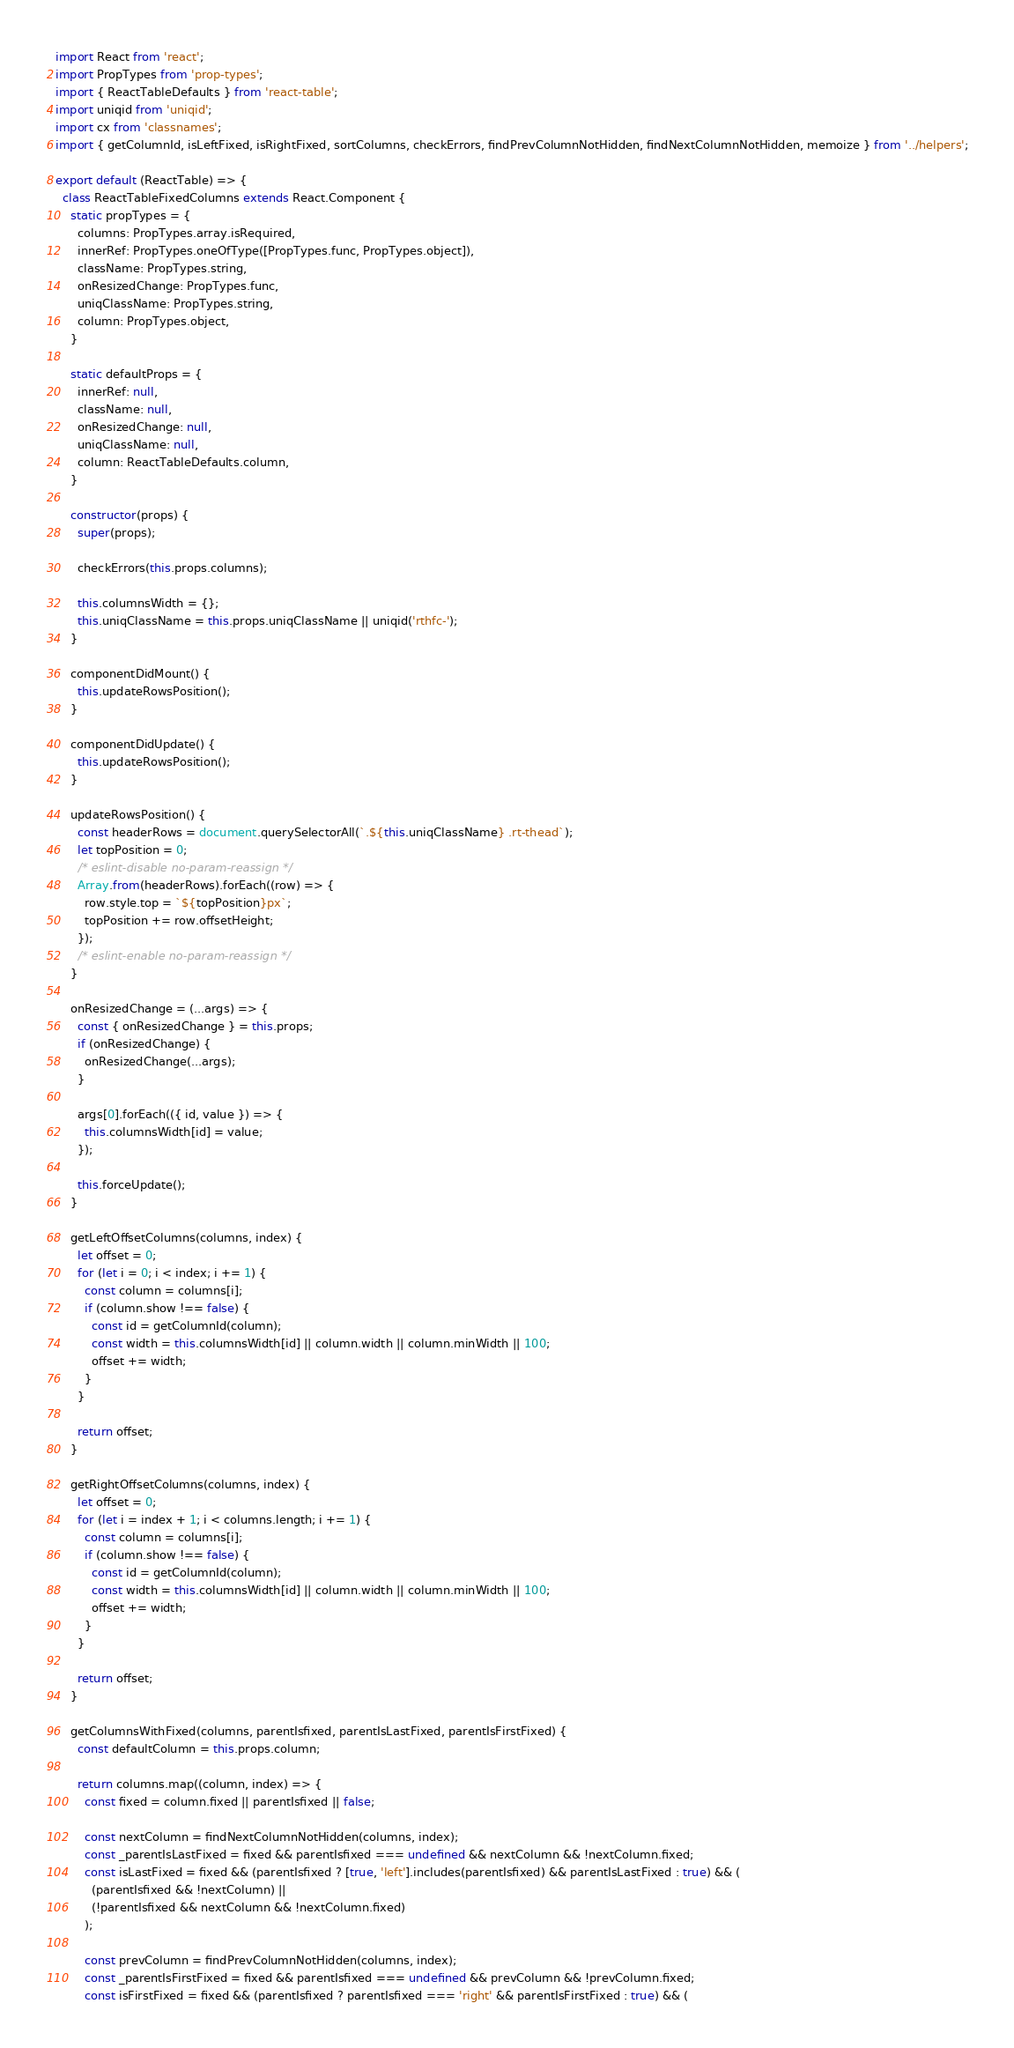<code> <loc_0><loc_0><loc_500><loc_500><_JavaScript_>import React from 'react';
import PropTypes from 'prop-types';
import { ReactTableDefaults } from 'react-table';
import uniqid from 'uniqid';
import cx from 'classnames';
import { getColumnId, isLeftFixed, isRightFixed, sortColumns, checkErrors, findPrevColumnNotHidden, findNextColumnNotHidden, memoize } from '../helpers';

export default (ReactTable) => {
  class ReactTableFixedColumns extends React.Component {
    static propTypes = {
      columns: PropTypes.array.isRequired,
      innerRef: PropTypes.oneOfType([PropTypes.func, PropTypes.object]),
      className: PropTypes.string,
      onResizedChange: PropTypes.func,
      uniqClassName: PropTypes.string,
      column: PropTypes.object,
    }

    static defaultProps = {
      innerRef: null,
      className: null,
      onResizedChange: null,
      uniqClassName: null,
      column: ReactTableDefaults.column,
    }

    constructor(props) {
      super(props);

      checkErrors(this.props.columns);

      this.columnsWidth = {};
      this.uniqClassName = this.props.uniqClassName || uniqid('rthfc-');
    }

    componentDidMount() {
      this.updateRowsPosition();
    }

    componentDidUpdate() {
      this.updateRowsPosition();
    }

    updateRowsPosition() {
      const headerRows = document.querySelectorAll(`.${this.uniqClassName} .rt-thead`);
      let topPosition = 0;
      /* eslint-disable no-param-reassign */
      Array.from(headerRows).forEach((row) => {
        row.style.top = `${topPosition}px`;
        topPosition += row.offsetHeight;
      });
      /* eslint-enable no-param-reassign */
    }

    onResizedChange = (...args) => {
      const { onResizedChange } = this.props;
      if (onResizedChange) {
        onResizedChange(...args);
      }

      args[0].forEach(({ id, value }) => {
        this.columnsWidth[id] = value;
      });

      this.forceUpdate();
    }

    getLeftOffsetColumns(columns, index) {
      let offset = 0;
      for (let i = 0; i < index; i += 1) {
        const column = columns[i];
        if (column.show !== false) {
          const id = getColumnId(column);
          const width = this.columnsWidth[id] || column.width || column.minWidth || 100;
          offset += width;
        }
      }

      return offset;
    }

    getRightOffsetColumns(columns, index) {
      let offset = 0;
      for (let i = index + 1; i < columns.length; i += 1) {
        const column = columns[i];
        if (column.show !== false) {
          const id = getColumnId(column);
          const width = this.columnsWidth[id] || column.width || column.minWidth || 100;
          offset += width;
        }
      }

      return offset;
    }

    getColumnsWithFixed(columns, parentIsfixed, parentIsLastFixed, parentIsFirstFixed) {
      const defaultColumn = this.props.column;

      return columns.map((column, index) => {
        const fixed = column.fixed || parentIsfixed || false;

        const nextColumn = findNextColumnNotHidden(columns, index);
        const _parentIsLastFixed = fixed && parentIsfixed === undefined && nextColumn && !nextColumn.fixed;
        const isLastFixed = fixed && (parentIsfixed ? [true, 'left'].includes(parentIsfixed) && parentIsLastFixed : true) && (
          (parentIsfixed && !nextColumn) ||
          (!parentIsfixed && nextColumn && !nextColumn.fixed)
        );

        const prevColumn = findPrevColumnNotHidden(columns, index);
        const _parentIsFirstFixed = fixed && parentIsfixed === undefined && prevColumn && !prevColumn.fixed;
        const isFirstFixed = fixed && (parentIsfixed ? parentIsfixed === 'right' && parentIsFirstFixed : true) && (</code> 